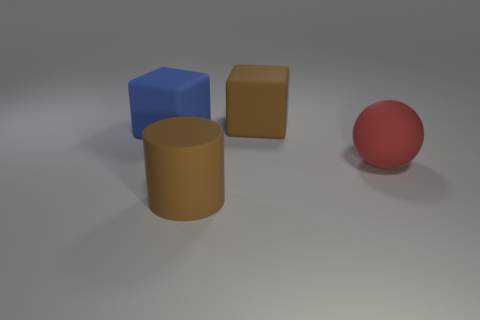Are there any other things that are the same shape as the big red matte thing?
Your response must be concise. No. What number of brown objects are behind the large block that is to the left of the brown matte cylinder?
Provide a succinct answer. 1. What number of big brown matte things have the same shape as the big red rubber thing?
Offer a terse response. 0. What number of purple metal cubes are there?
Make the answer very short. 0. There is a big object that is in front of the sphere; what is its color?
Offer a very short reply. Brown. The rubber thing on the left side of the large brown rubber thing that is in front of the large red matte thing is what color?
Your answer should be very brief. Blue. What color is the cylinder that is the same size as the red ball?
Keep it short and to the point. Brown. How many rubber things are both to the right of the big blue block and to the left of the brown cylinder?
Make the answer very short. 0. The big object that is the same color as the matte cylinder is what shape?
Keep it short and to the point. Cube. The large thing that is both on the left side of the brown block and to the right of the big blue block is made of what material?
Your response must be concise. Rubber. 